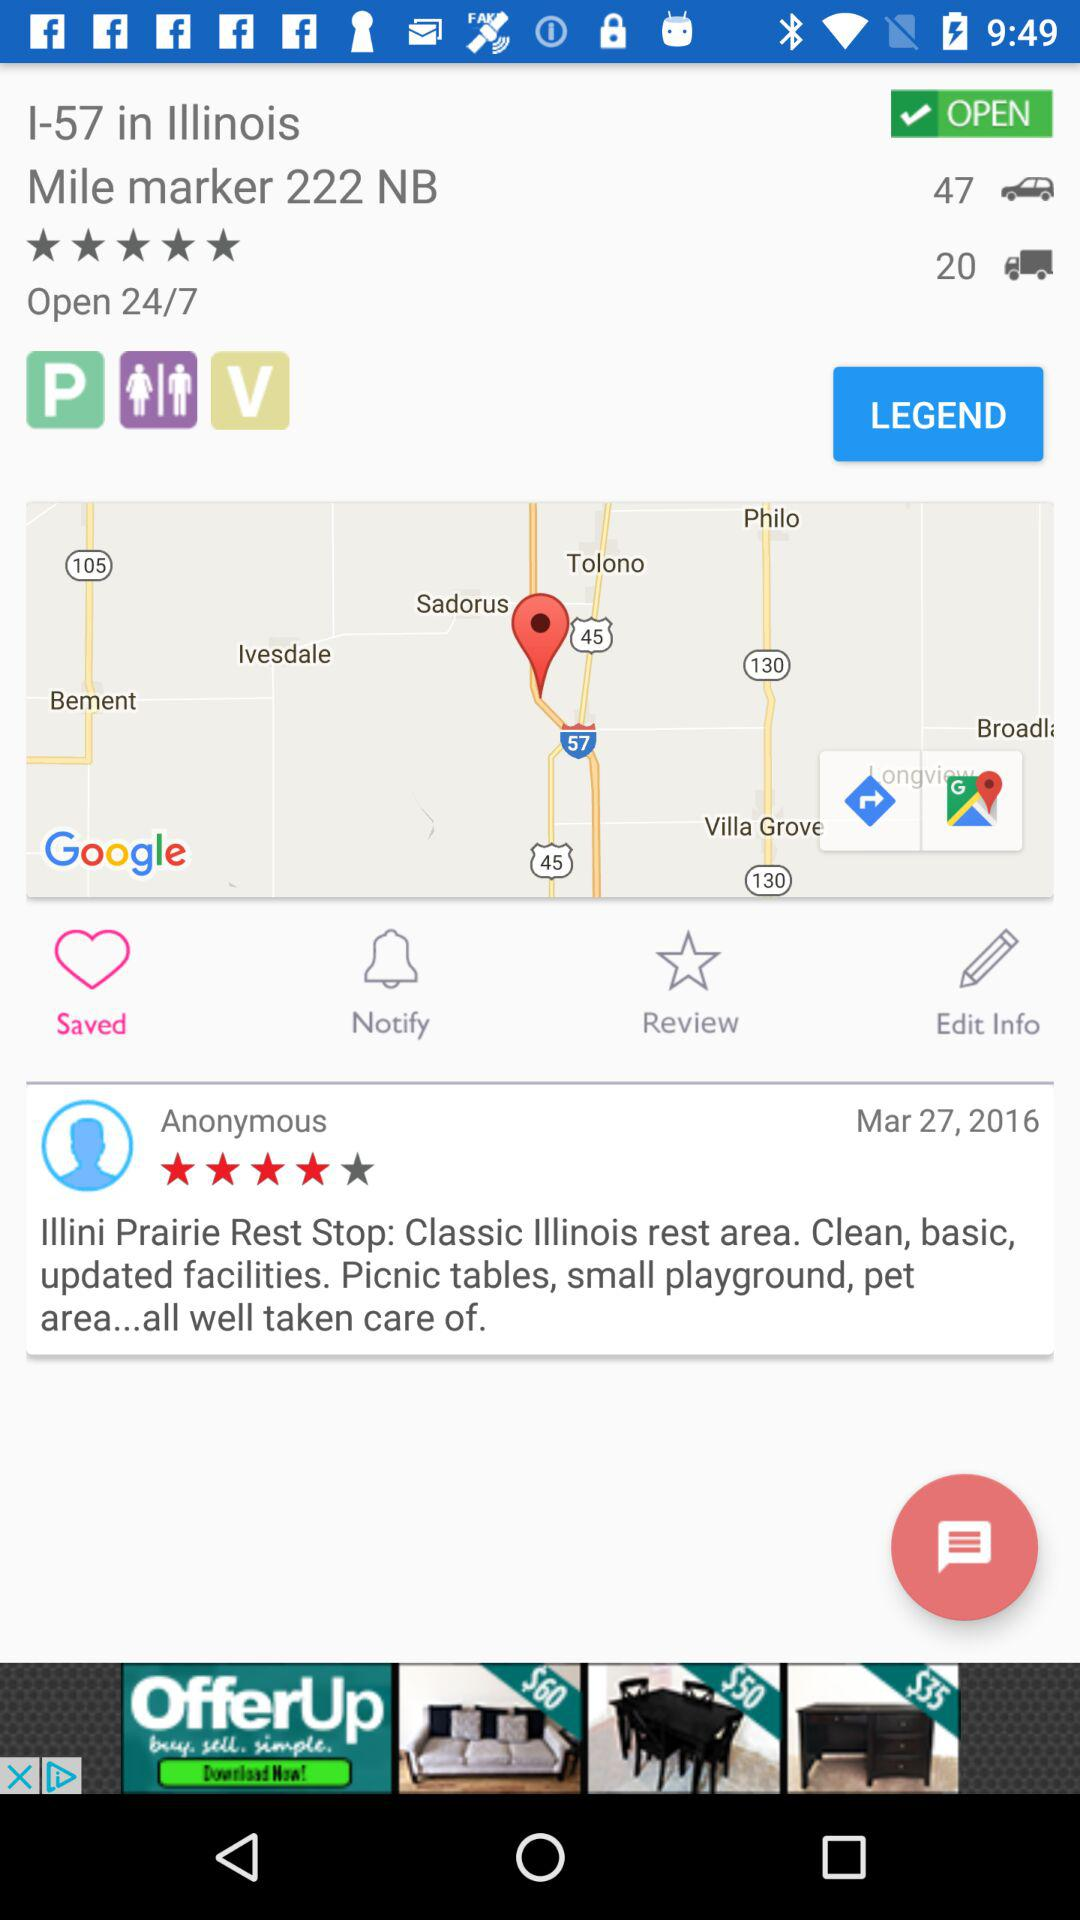What is the address? The address is I-57 in Illinois Mile marker 222 NB. 